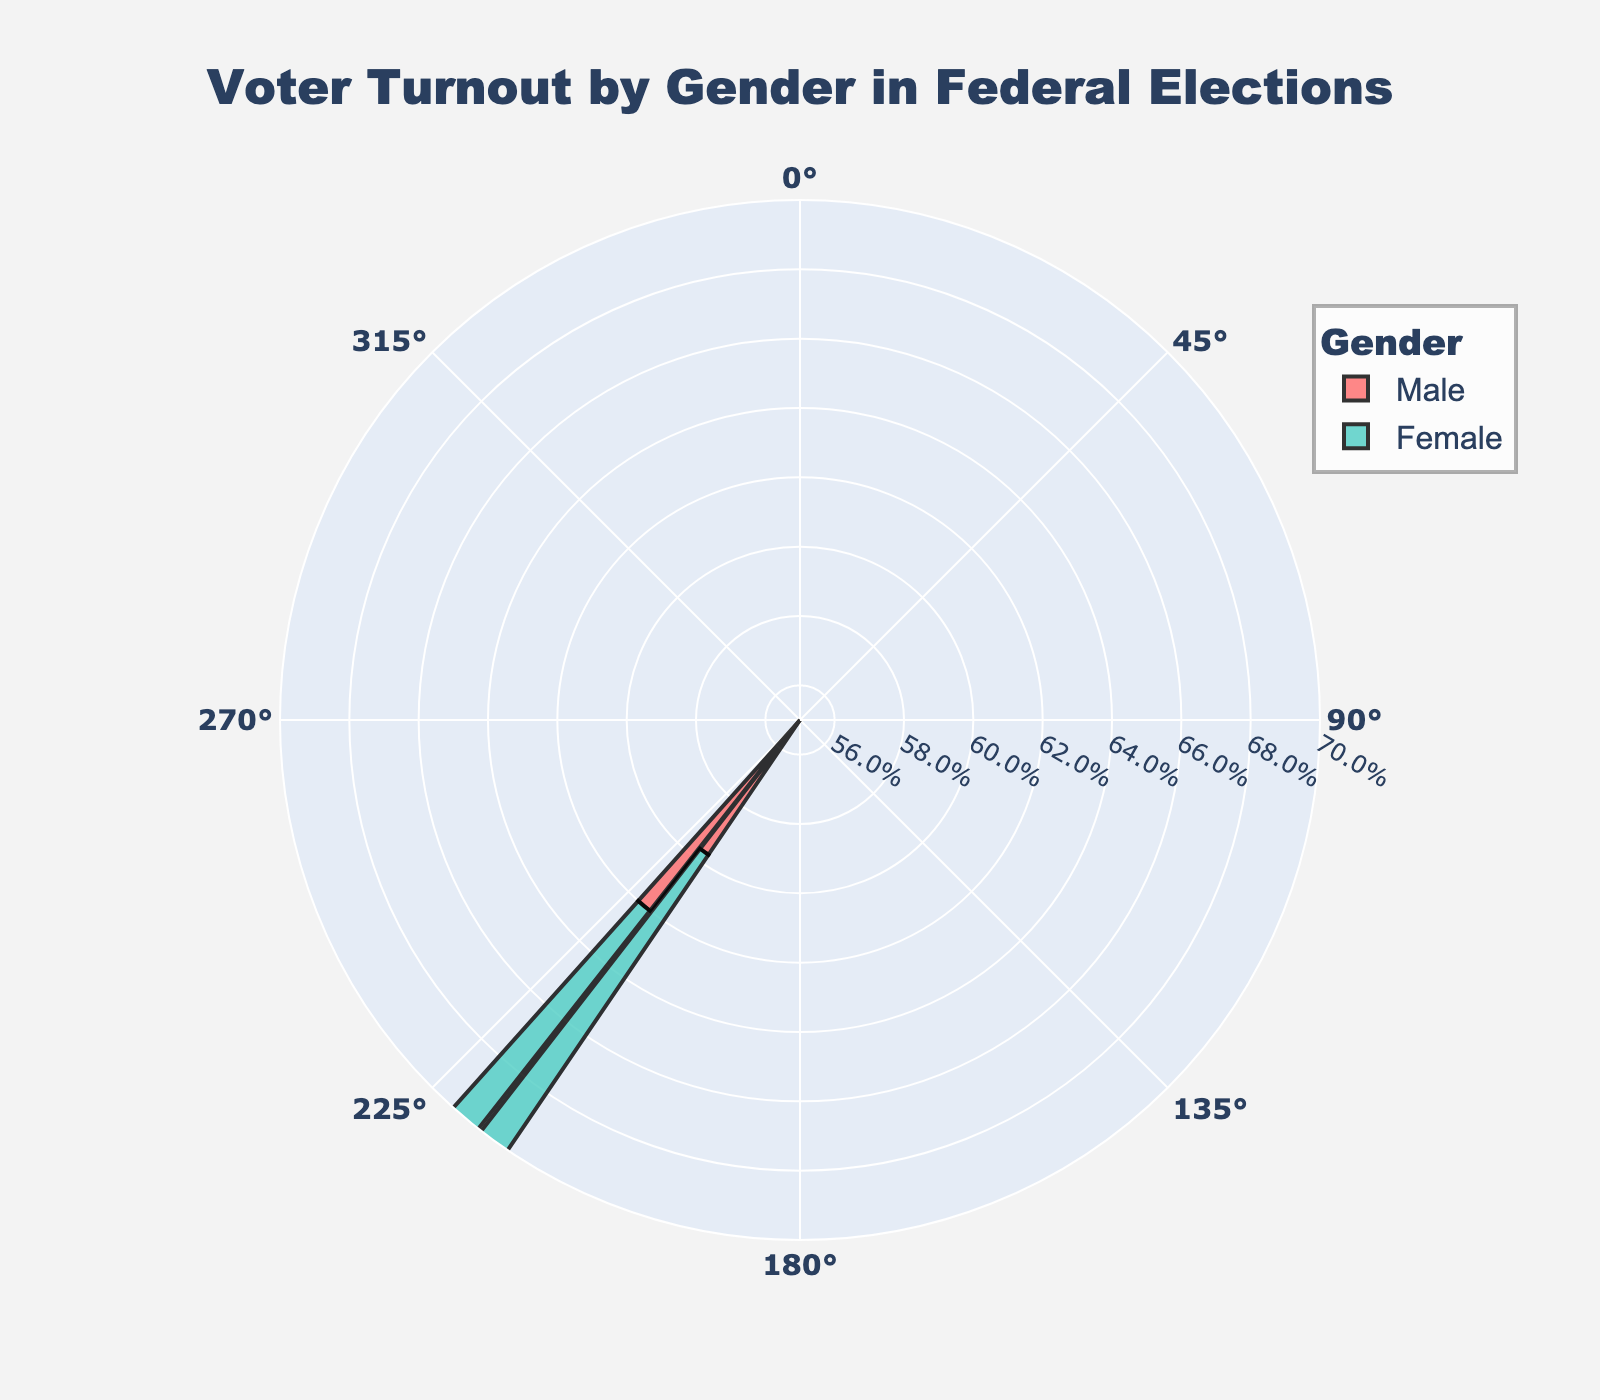What is the title of the chart? The title is written at the top of the chart in large font.
Answer: Voter Turnout by Gender in Federal Elections How many gender groups are displayed in the chart? The chart contains two distinct labels in the legend section corresponding to gender.
Answer: 2 Which gender had a higher voter turnout percentage in 2016? By examining the lengths of the bars for each gender in 2016, the longer bar represents the greater percentage.
Answer: Female How much did male voter turnout percentage increase from 2016 to 2020? Subtract the male voter turnout percentage in 2016 from that in 2020 (62.0% - 59.7%).
Answer: 2.3% What is the average voter turnout percentage for females across the years displayed? Add the female turnout percentages for 2016 and 2020 and divide by 2: (63.3% + 65.5%) / 2.
Answer: 64.4% Compare the gender with the higher voter turnout in 2020. Observe the bars for the year 2020 and identify which gender has the longer bar.
Answer: Female What range of percentages does the radial axis cover? Look at the radial axis labels which indicate the range of voter turnout percentages.
Answer: 55% to 70% Which gender had the smallest change in voter turnout percentage between 2016 and 2020? Calculate the differences for each gender: Female (65.5% - 63.3%) and Male (62.0% - 59.7%), then compare.
Answer: Female During which year was the voter turnout percentage for males closest to the voter turnout percentage for females? Subtract the male percentage from the female percentage for both years and determine the smaller difference: 2020 (65.5% - 62.0%) vs 2016 (63.3% - 59.7%).
Answer: 2020 What is the percentage difference between the highest single voter turnout and the lowest single voter turnout in the chart? Identify the highest and lowest turnout percentages then subtract: highest (65.5%) - lowest (59.7%).
Answer: 5.8% 